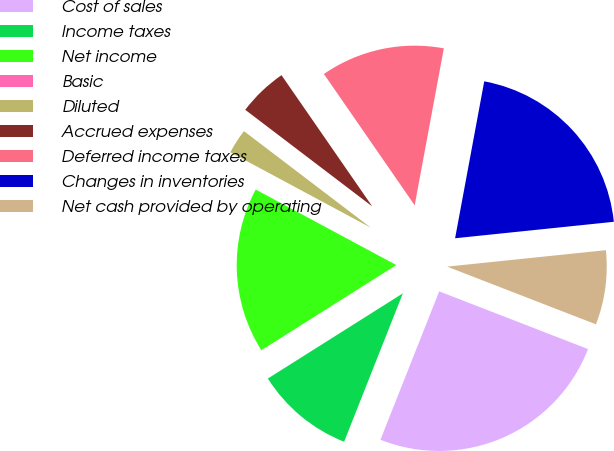<chart> <loc_0><loc_0><loc_500><loc_500><pie_chart><fcel>Cost of sales<fcel>Income taxes<fcel>Net income<fcel>Basic<fcel>Diluted<fcel>Accrued expenses<fcel>Deferred income taxes<fcel>Changes in inventories<fcel>Net cash provided by operating<nl><fcel>25.11%<fcel>10.04%<fcel>16.8%<fcel>0.0%<fcel>2.51%<fcel>5.02%<fcel>12.55%<fcel>20.43%<fcel>7.53%<nl></chart> 